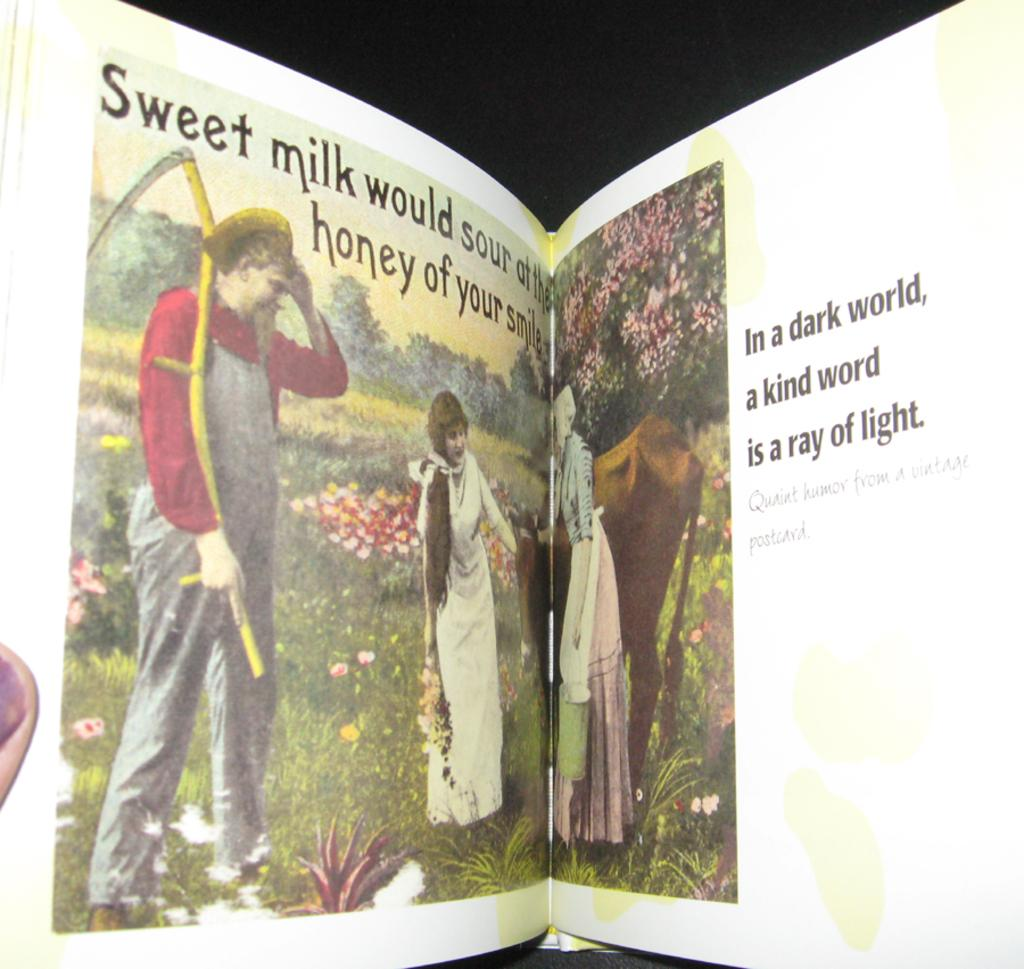<image>
Describe the image concisely. A partially open book with pictures that reads "In a dark world, a kind word is a ray of light." 